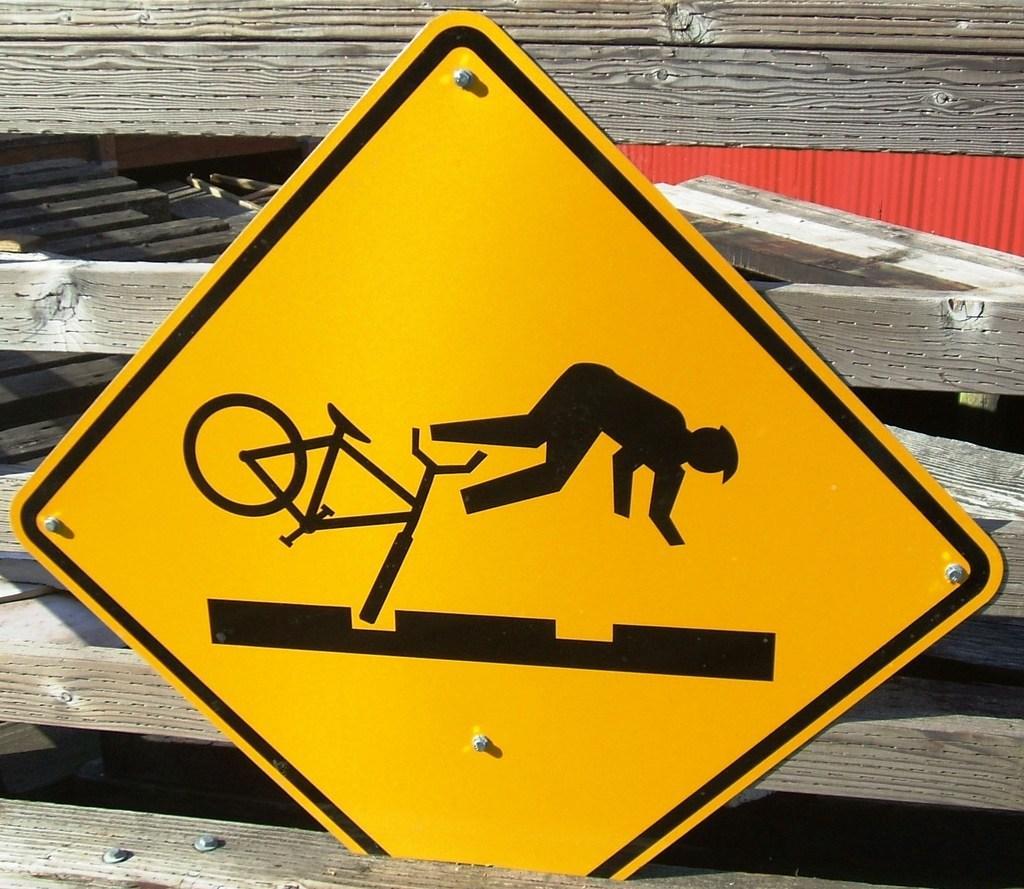Describe this image in one or two sentences. In this image I can see a sign board attached to the wooden bars. In this sign board I can see a person falling down with a bicycle indicating speed breakers on the road. 